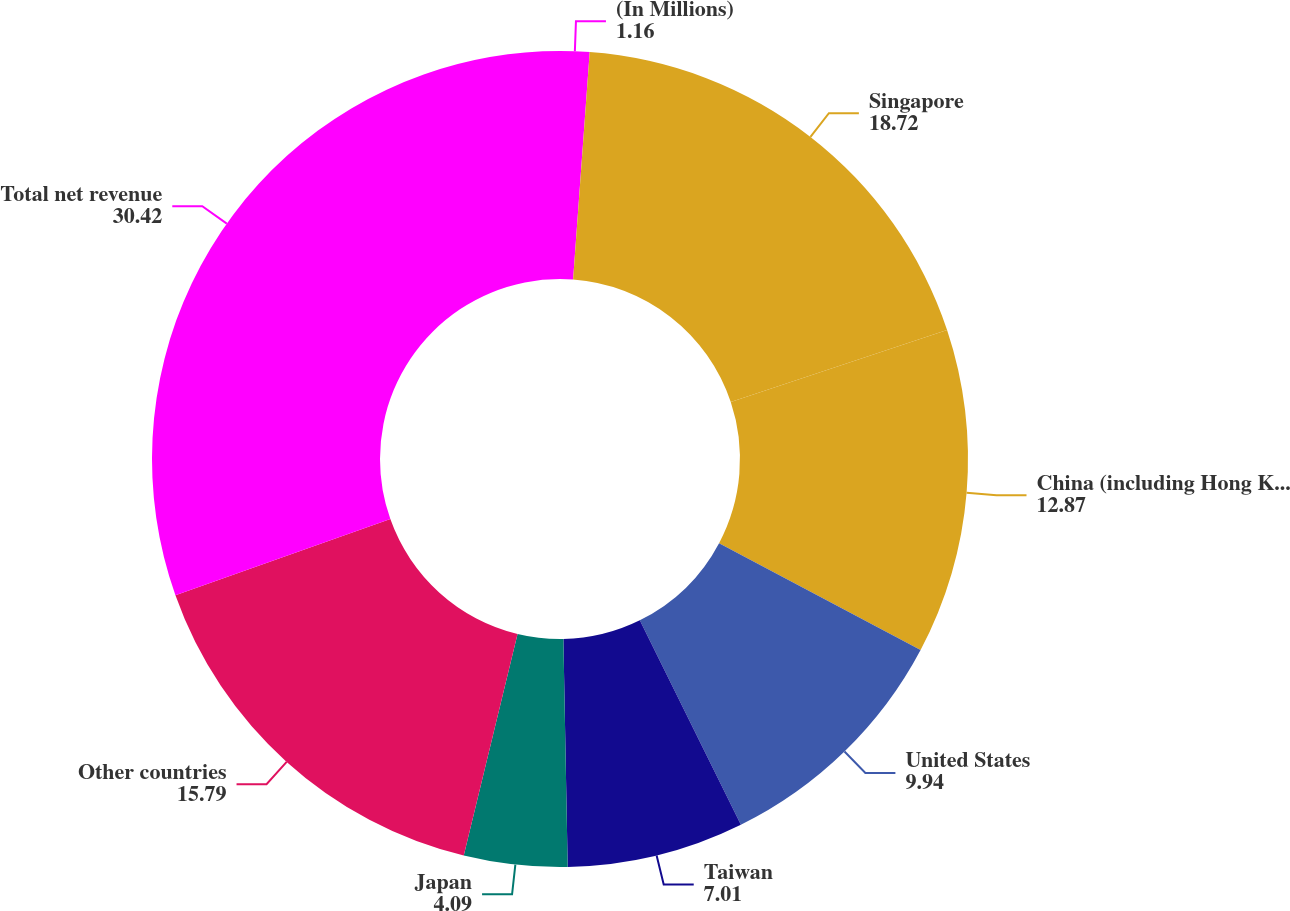Convert chart to OTSL. <chart><loc_0><loc_0><loc_500><loc_500><pie_chart><fcel>(In Millions)<fcel>Singapore<fcel>China (including Hong Kong)<fcel>United States<fcel>Taiwan<fcel>Japan<fcel>Other countries<fcel>Total net revenue<nl><fcel>1.16%<fcel>18.72%<fcel>12.87%<fcel>9.94%<fcel>7.01%<fcel>4.09%<fcel>15.79%<fcel>30.42%<nl></chart> 